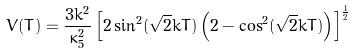<formula> <loc_0><loc_0><loc_500><loc_500>V ( T ) = \frac { 3 k ^ { 2 } } { \kappa _ { 5 } ^ { 2 } } \left [ 2 \sin ^ { 2 } ( \sqrt { 2 } k T ) \left ( 2 - \cos ^ { 2 } ( \sqrt { 2 } k T ) \right ) \right ] ^ { \frac { 1 } { 2 } }</formula> 